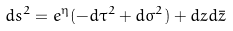Convert formula to latex. <formula><loc_0><loc_0><loc_500><loc_500>d s ^ { 2 } = e ^ { \eta } ( - d \tau ^ { 2 } + d \sigma ^ { 2 } ) + d z d \bar { z }</formula> 